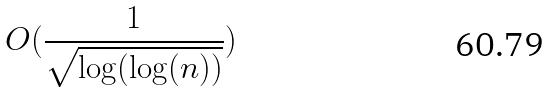<formula> <loc_0><loc_0><loc_500><loc_500>O ( \frac { 1 } { \sqrt { \log ( \log ( n ) ) } } )</formula> 